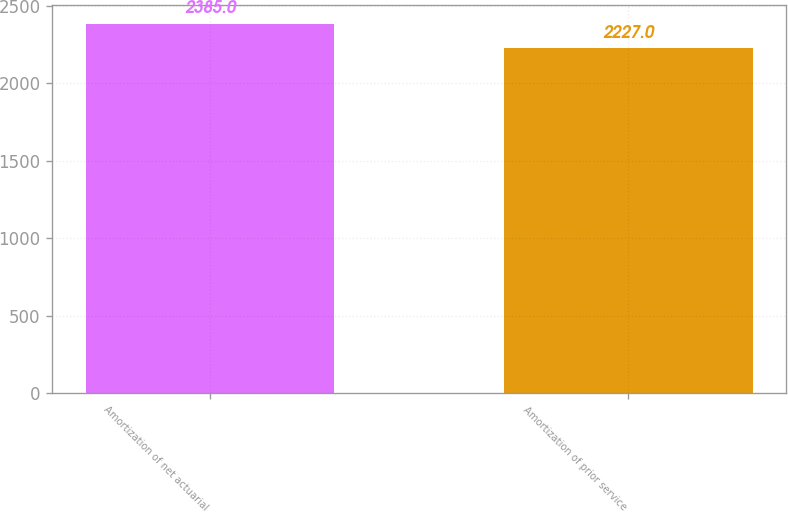Convert chart. <chart><loc_0><loc_0><loc_500><loc_500><bar_chart><fcel>Amortization of net actuarial<fcel>Amortization of prior service<nl><fcel>2385<fcel>2227<nl></chart> 